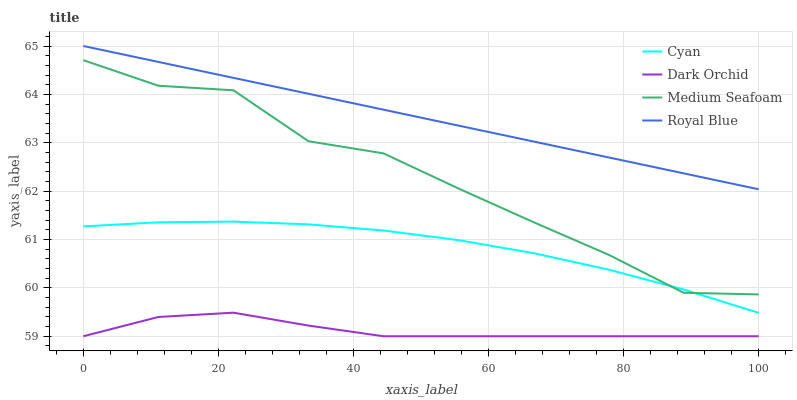Does Medium Seafoam have the minimum area under the curve?
Answer yes or no. No. Does Medium Seafoam have the maximum area under the curve?
Answer yes or no. No. Is Dark Orchid the smoothest?
Answer yes or no. No. Is Dark Orchid the roughest?
Answer yes or no. No. Does Medium Seafoam have the lowest value?
Answer yes or no. No. Does Medium Seafoam have the highest value?
Answer yes or no. No. Is Medium Seafoam less than Royal Blue?
Answer yes or no. Yes. Is Royal Blue greater than Cyan?
Answer yes or no. Yes. Does Medium Seafoam intersect Royal Blue?
Answer yes or no. No. 